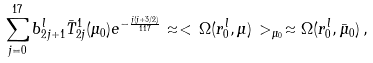<formula> <loc_0><loc_0><loc_500><loc_500>\sum _ { j = 0 } ^ { 1 7 } b _ { 2 j + 1 } ^ { l } \bar { T } _ { 2 j } ^ { 1 } ( \mu _ { 0 } ) e ^ { - \frac { j ( j + 3 / 2 ) } { 1 1 7 } } \approx < \, \Omega ( r _ { 0 } ^ { l } , \mu ) \, > _ { \mu _ { 0 } } \approx \Omega ( r _ { 0 } ^ { l } , \bar { \mu } _ { 0 } ) \, ,</formula> 